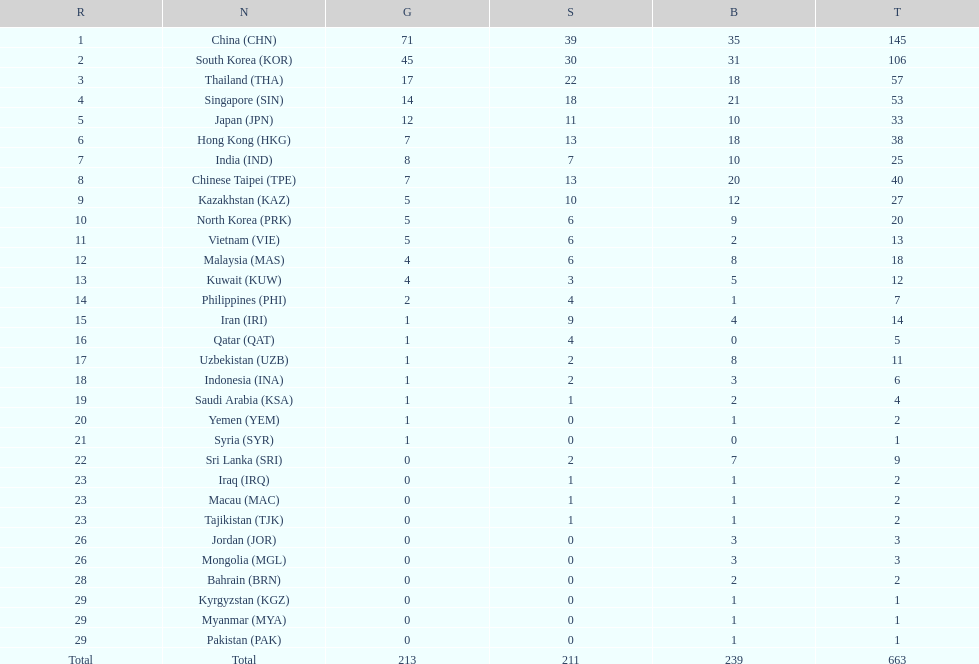What is the total number of medals that india won in the asian youth games? 25. 